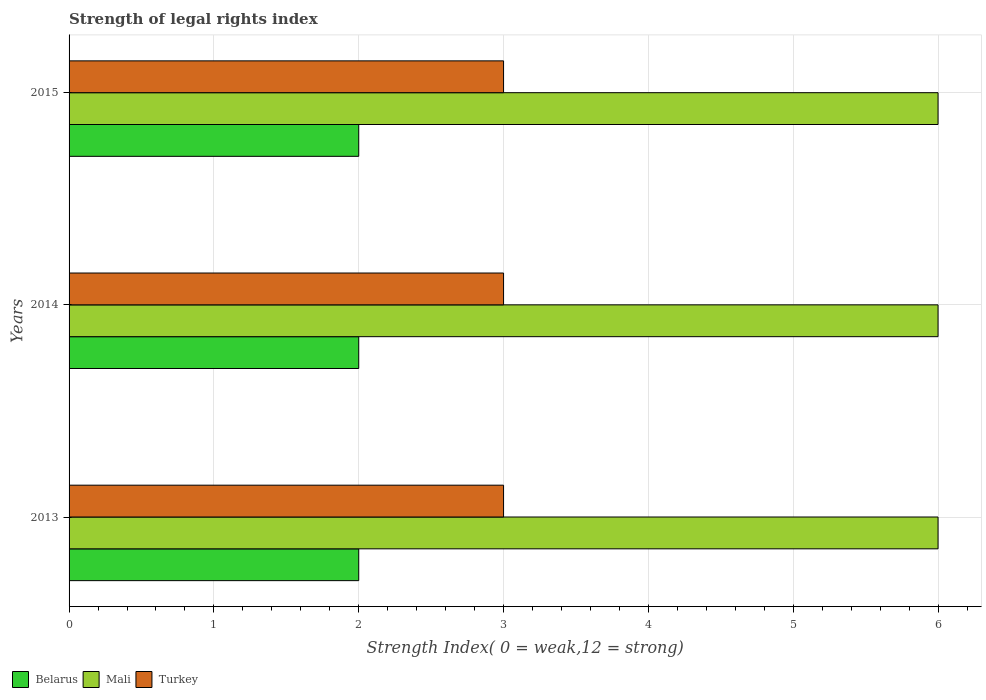How many different coloured bars are there?
Your response must be concise. 3. Are the number of bars on each tick of the Y-axis equal?
Your answer should be very brief. Yes. What is the label of the 1st group of bars from the top?
Provide a short and direct response. 2015. What is the strength index in Mali in 2015?
Your response must be concise. 6. Across all years, what is the maximum strength index in Mali?
Your answer should be very brief. 6. Across all years, what is the minimum strength index in Mali?
Ensure brevity in your answer.  6. In which year was the strength index in Mali maximum?
Offer a terse response. 2013. What is the difference between the strength index in Mali in 2014 and the strength index in Turkey in 2013?
Provide a short and direct response. 3. What is the average strength index in Belarus per year?
Give a very brief answer. 2. In the year 2015, what is the difference between the strength index in Turkey and strength index in Belarus?
Your answer should be very brief. 1. In how many years, is the strength index in Turkey greater than 0.6000000000000001 ?
Your answer should be very brief. 3. Is the difference between the strength index in Turkey in 2013 and 2014 greater than the difference between the strength index in Belarus in 2013 and 2014?
Your response must be concise. No. What is the difference between the highest and the lowest strength index in Mali?
Provide a succinct answer. 0. Is the sum of the strength index in Mali in 2013 and 2014 greater than the maximum strength index in Turkey across all years?
Keep it short and to the point. Yes. What does the 1st bar from the top in 2014 represents?
Keep it short and to the point. Turkey. What does the 1st bar from the bottom in 2015 represents?
Your answer should be very brief. Belarus. What is the title of the graph?
Provide a succinct answer. Strength of legal rights index. What is the label or title of the X-axis?
Offer a terse response. Strength Index( 0 = weak,12 = strong). What is the label or title of the Y-axis?
Your answer should be compact. Years. What is the Strength Index( 0 = weak,12 = strong) in Mali in 2013?
Your answer should be very brief. 6. What is the Strength Index( 0 = weak,12 = strong) in Belarus in 2014?
Offer a very short reply. 2. What is the Strength Index( 0 = weak,12 = strong) in Turkey in 2014?
Give a very brief answer. 3. What is the Strength Index( 0 = weak,12 = strong) of Belarus in 2015?
Your answer should be very brief. 2. Across all years, what is the maximum Strength Index( 0 = weak,12 = strong) of Belarus?
Ensure brevity in your answer.  2. Across all years, what is the maximum Strength Index( 0 = weak,12 = strong) in Turkey?
Ensure brevity in your answer.  3. Across all years, what is the minimum Strength Index( 0 = weak,12 = strong) in Mali?
Provide a short and direct response. 6. What is the total Strength Index( 0 = weak,12 = strong) of Belarus in the graph?
Give a very brief answer. 6. What is the total Strength Index( 0 = weak,12 = strong) of Turkey in the graph?
Offer a terse response. 9. What is the difference between the Strength Index( 0 = weak,12 = strong) in Mali in 2013 and that in 2014?
Make the answer very short. 0. What is the difference between the Strength Index( 0 = weak,12 = strong) in Turkey in 2013 and that in 2014?
Make the answer very short. 0. What is the difference between the Strength Index( 0 = weak,12 = strong) in Belarus in 2013 and that in 2015?
Your answer should be compact. 0. What is the difference between the Strength Index( 0 = weak,12 = strong) in Belarus in 2014 and that in 2015?
Make the answer very short. 0. What is the difference between the Strength Index( 0 = weak,12 = strong) in Belarus in 2013 and the Strength Index( 0 = weak,12 = strong) in Mali in 2014?
Keep it short and to the point. -4. What is the difference between the Strength Index( 0 = weak,12 = strong) in Mali in 2013 and the Strength Index( 0 = weak,12 = strong) in Turkey in 2014?
Your answer should be compact. 3. What is the difference between the Strength Index( 0 = weak,12 = strong) of Belarus in 2013 and the Strength Index( 0 = weak,12 = strong) of Mali in 2015?
Your answer should be very brief. -4. What is the difference between the Strength Index( 0 = weak,12 = strong) in Belarus in 2013 and the Strength Index( 0 = weak,12 = strong) in Turkey in 2015?
Offer a terse response. -1. What is the difference between the Strength Index( 0 = weak,12 = strong) in Mali in 2013 and the Strength Index( 0 = weak,12 = strong) in Turkey in 2015?
Ensure brevity in your answer.  3. What is the difference between the Strength Index( 0 = weak,12 = strong) in Belarus in 2014 and the Strength Index( 0 = weak,12 = strong) in Mali in 2015?
Your answer should be compact. -4. What is the difference between the Strength Index( 0 = weak,12 = strong) of Belarus in 2014 and the Strength Index( 0 = weak,12 = strong) of Turkey in 2015?
Give a very brief answer. -1. What is the average Strength Index( 0 = weak,12 = strong) of Belarus per year?
Provide a short and direct response. 2. What is the average Strength Index( 0 = weak,12 = strong) in Mali per year?
Your answer should be very brief. 6. What is the average Strength Index( 0 = weak,12 = strong) in Turkey per year?
Give a very brief answer. 3. In the year 2013, what is the difference between the Strength Index( 0 = weak,12 = strong) of Belarus and Strength Index( 0 = weak,12 = strong) of Turkey?
Make the answer very short. -1. In the year 2013, what is the difference between the Strength Index( 0 = weak,12 = strong) in Mali and Strength Index( 0 = weak,12 = strong) in Turkey?
Your answer should be very brief. 3. In the year 2014, what is the difference between the Strength Index( 0 = weak,12 = strong) in Belarus and Strength Index( 0 = weak,12 = strong) in Mali?
Give a very brief answer. -4. In the year 2014, what is the difference between the Strength Index( 0 = weak,12 = strong) of Belarus and Strength Index( 0 = weak,12 = strong) of Turkey?
Keep it short and to the point. -1. In the year 2014, what is the difference between the Strength Index( 0 = weak,12 = strong) in Mali and Strength Index( 0 = weak,12 = strong) in Turkey?
Give a very brief answer. 3. In the year 2015, what is the difference between the Strength Index( 0 = weak,12 = strong) in Belarus and Strength Index( 0 = weak,12 = strong) in Mali?
Your response must be concise. -4. In the year 2015, what is the difference between the Strength Index( 0 = weak,12 = strong) of Belarus and Strength Index( 0 = weak,12 = strong) of Turkey?
Your answer should be very brief. -1. What is the ratio of the Strength Index( 0 = weak,12 = strong) in Mali in 2013 to that in 2014?
Keep it short and to the point. 1. What is the ratio of the Strength Index( 0 = weak,12 = strong) of Turkey in 2013 to that in 2014?
Provide a short and direct response. 1. What is the ratio of the Strength Index( 0 = weak,12 = strong) in Turkey in 2013 to that in 2015?
Offer a terse response. 1. What is the ratio of the Strength Index( 0 = weak,12 = strong) of Belarus in 2014 to that in 2015?
Your answer should be very brief. 1. What is the ratio of the Strength Index( 0 = weak,12 = strong) of Mali in 2014 to that in 2015?
Give a very brief answer. 1. What is the difference between the highest and the second highest Strength Index( 0 = weak,12 = strong) in Belarus?
Offer a terse response. 0. 